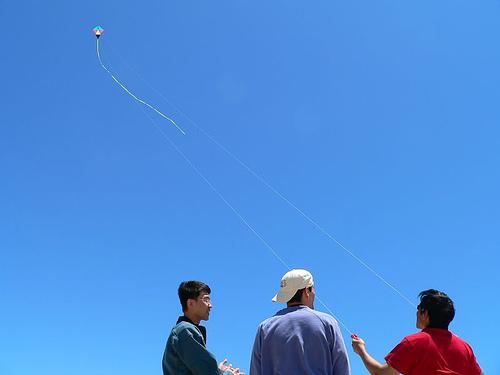Is anyone wearing glasses?
Short answer required. Yes. How many kites in the air?
Keep it brief. 1. What do you think they are doing?
Be succinct. Flying kite. 